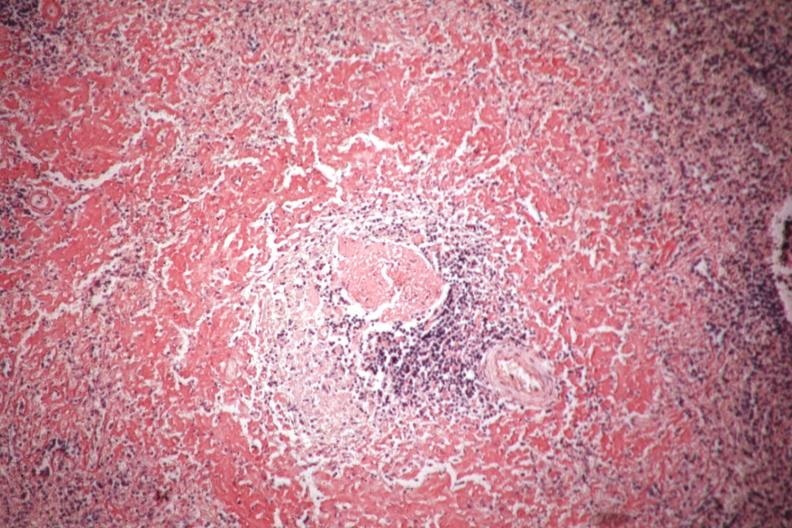does hemochromatosis show congo red well shown perifollicular amyloid?
Answer the question using a single word or phrase. No 